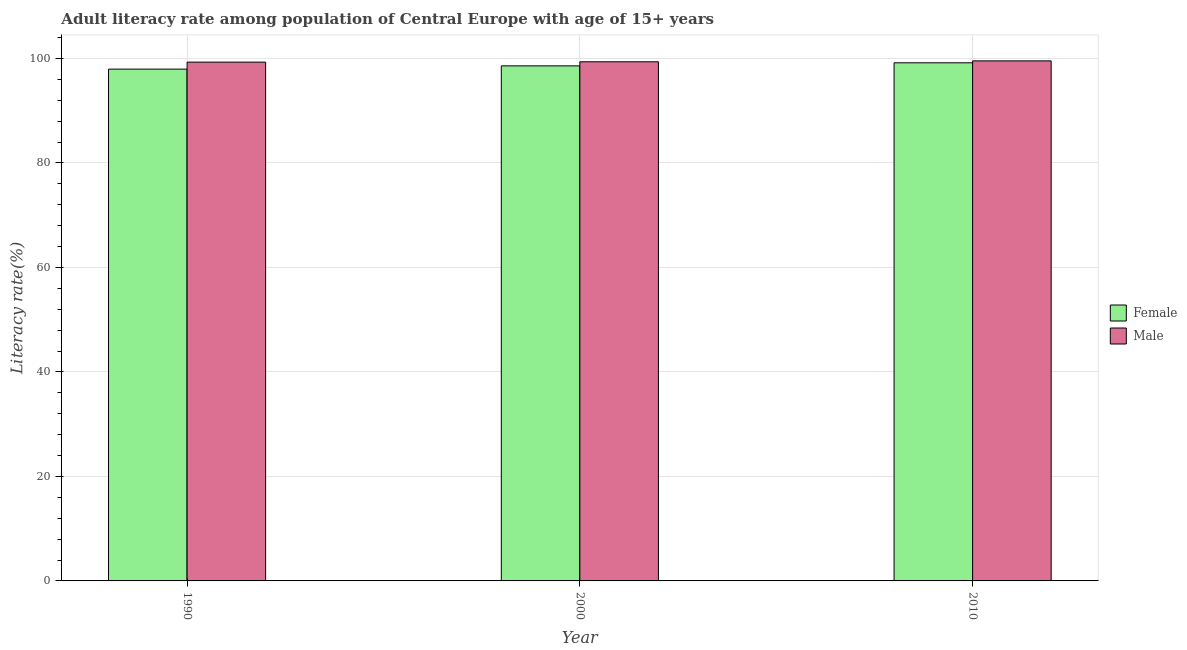How many different coloured bars are there?
Give a very brief answer. 2. How many groups of bars are there?
Provide a short and direct response. 3. Are the number of bars per tick equal to the number of legend labels?
Give a very brief answer. Yes. Are the number of bars on each tick of the X-axis equal?
Your response must be concise. Yes. How many bars are there on the 1st tick from the left?
Your answer should be very brief. 2. What is the male adult literacy rate in 1990?
Give a very brief answer. 99.29. Across all years, what is the maximum male adult literacy rate?
Ensure brevity in your answer.  99.53. Across all years, what is the minimum female adult literacy rate?
Your answer should be very brief. 97.96. In which year was the male adult literacy rate maximum?
Ensure brevity in your answer.  2010. In which year was the male adult literacy rate minimum?
Offer a very short reply. 1990. What is the total male adult literacy rate in the graph?
Offer a very short reply. 298.19. What is the difference between the female adult literacy rate in 2000 and that in 2010?
Your answer should be compact. -0.59. What is the difference between the male adult literacy rate in 1990 and the female adult literacy rate in 2010?
Provide a succinct answer. -0.24. What is the average male adult literacy rate per year?
Keep it short and to the point. 99.4. In how many years, is the male adult literacy rate greater than 28 %?
Your answer should be compact. 3. What is the ratio of the female adult literacy rate in 1990 to that in 2000?
Provide a succinct answer. 0.99. Is the difference between the female adult literacy rate in 1990 and 2010 greater than the difference between the male adult literacy rate in 1990 and 2010?
Offer a terse response. No. What is the difference between the highest and the second highest female adult literacy rate?
Your answer should be compact. 0.59. What is the difference between the highest and the lowest female adult literacy rate?
Ensure brevity in your answer.  1.21. In how many years, is the female adult literacy rate greater than the average female adult literacy rate taken over all years?
Your answer should be compact. 2. Is the sum of the male adult literacy rate in 2000 and 2010 greater than the maximum female adult literacy rate across all years?
Offer a terse response. Yes. What does the 1st bar from the left in 2000 represents?
Your answer should be very brief. Female. What does the 1st bar from the right in 1990 represents?
Your answer should be compact. Male. How many bars are there?
Provide a short and direct response. 6. What is the difference between two consecutive major ticks on the Y-axis?
Your answer should be compact. 20. How are the legend labels stacked?
Your answer should be compact. Vertical. What is the title of the graph?
Offer a terse response. Adult literacy rate among population of Central Europe with age of 15+ years. Does "DAC donors" appear as one of the legend labels in the graph?
Provide a succinct answer. No. What is the label or title of the X-axis?
Provide a short and direct response. Year. What is the label or title of the Y-axis?
Keep it short and to the point. Literacy rate(%). What is the Literacy rate(%) in Female in 1990?
Your answer should be compact. 97.96. What is the Literacy rate(%) of Male in 1990?
Offer a very short reply. 99.29. What is the Literacy rate(%) of Female in 2000?
Give a very brief answer. 98.58. What is the Literacy rate(%) in Male in 2000?
Offer a very short reply. 99.36. What is the Literacy rate(%) of Female in 2010?
Offer a very short reply. 99.16. What is the Literacy rate(%) of Male in 2010?
Your answer should be very brief. 99.53. Across all years, what is the maximum Literacy rate(%) in Female?
Keep it short and to the point. 99.16. Across all years, what is the maximum Literacy rate(%) in Male?
Keep it short and to the point. 99.53. Across all years, what is the minimum Literacy rate(%) in Female?
Provide a succinct answer. 97.96. Across all years, what is the minimum Literacy rate(%) in Male?
Your answer should be compact. 99.29. What is the total Literacy rate(%) of Female in the graph?
Ensure brevity in your answer.  295.7. What is the total Literacy rate(%) in Male in the graph?
Your answer should be very brief. 298.19. What is the difference between the Literacy rate(%) of Female in 1990 and that in 2000?
Provide a succinct answer. -0.62. What is the difference between the Literacy rate(%) of Male in 1990 and that in 2000?
Offer a terse response. -0.07. What is the difference between the Literacy rate(%) in Female in 1990 and that in 2010?
Keep it short and to the point. -1.21. What is the difference between the Literacy rate(%) of Male in 1990 and that in 2010?
Offer a terse response. -0.24. What is the difference between the Literacy rate(%) of Female in 2000 and that in 2010?
Make the answer very short. -0.59. What is the difference between the Literacy rate(%) of Male in 2000 and that in 2010?
Ensure brevity in your answer.  -0.17. What is the difference between the Literacy rate(%) in Female in 1990 and the Literacy rate(%) in Male in 2000?
Make the answer very short. -1.4. What is the difference between the Literacy rate(%) in Female in 1990 and the Literacy rate(%) in Male in 2010?
Your response must be concise. -1.58. What is the difference between the Literacy rate(%) in Female in 2000 and the Literacy rate(%) in Male in 2010?
Your answer should be very brief. -0.96. What is the average Literacy rate(%) of Female per year?
Ensure brevity in your answer.  98.57. What is the average Literacy rate(%) of Male per year?
Your answer should be very brief. 99.4. In the year 1990, what is the difference between the Literacy rate(%) of Female and Literacy rate(%) of Male?
Offer a very short reply. -1.34. In the year 2000, what is the difference between the Literacy rate(%) in Female and Literacy rate(%) in Male?
Give a very brief answer. -0.78. In the year 2010, what is the difference between the Literacy rate(%) in Female and Literacy rate(%) in Male?
Ensure brevity in your answer.  -0.37. What is the ratio of the Literacy rate(%) of Male in 1990 to that in 2000?
Your response must be concise. 1. What is the ratio of the Literacy rate(%) in Female in 2000 to that in 2010?
Give a very brief answer. 0.99. What is the ratio of the Literacy rate(%) in Male in 2000 to that in 2010?
Offer a terse response. 1. What is the difference between the highest and the second highest Literacy rate(%) of Female?
Provide a short and direct response. 0.59. What is the difference between the highest and the second highest Literacy rate(%) in Male?
Your response must be concise. 0.17. What is the difference between the highest and the lowest Literacy rate(%) of Female?
Your answer should be compact. 1.21. What is the difference between the highest and the lowest Literacy rate(%) in Male?
Provide a short and direct response. 0.24. 